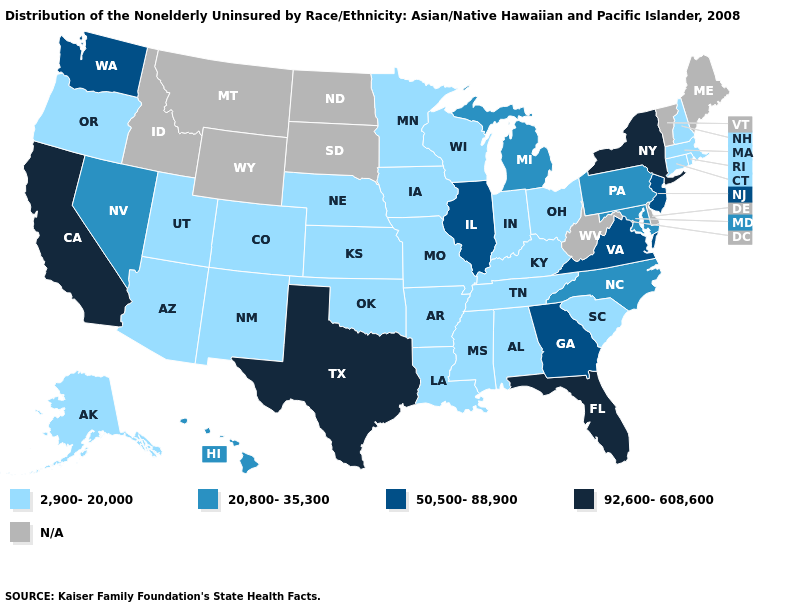Name the states that have a value in the range 92,600-608,600?
Be succinct. California, Florida, New York, Texas. How many symbols are there in the legend?
Write a very short answer. 5. Among the states that border Kentucky , which have the highest value?
Short answer required. Illinois, Virginia. Among the states that border New York , which have the lowest value?
Be succinct. Connecticut, Massachusetts. Among the states that border Oklahoma , which have the highest value?
Keep it brief. Texas. What is the lowest value in the USA?
Answer briefly. 2,900-20,000. Name the states that have a value in the range 92,600-608,600?
Be succinct. California, Florida, New York, Texas. What is the lowest value in states that border Massachusetts?
Concise answer only. 2,900-20,000. What is the value of Iowa?
Write a very short answer. 2,900-20,000. What is the value of Connecticut?
Short answer required. 2,900-20,000. What is the highest value in the West ?
Quick response, please. 92,600-608,600. Name the states that have a value in the range 50,500-88,900?
Quick response, please. Georgia, Illinois, New Jersey, Virginia, Washington. Name the states that have a value in the range 2,900-20,000?
Be succinct. Alabama, Alaska, Arizona, Arkansas, Colorado, Connecticut, Indiana, Iowa, Kansas, Kentucky, Louisiana, Massachusetts, Minnesota, Mississippi, Missouri, Nebraska, New Hampshire, New Mexico, Ohio, Oklahoma, Oregon, Rhode Island, South Carolina, Tennessee, Utah, Wisconsin. Does Hawaii have the lowest value in the West?
Quick response, please. No. Does Mississippi have the lowest value in the USA?
Be succinct. Yes. 